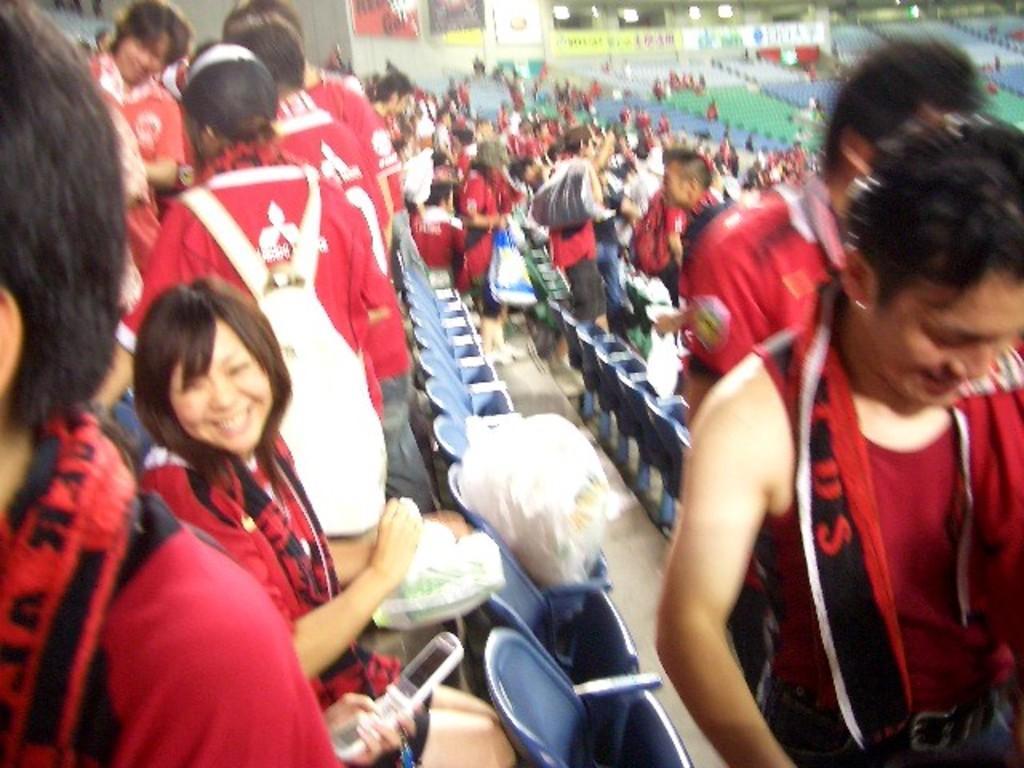How would you summarize this image in a sentence or two? In this image I can see a group of people Few people are sitting and few are walking and holding a bags. They are wearing red color dress. I can see chairs. 